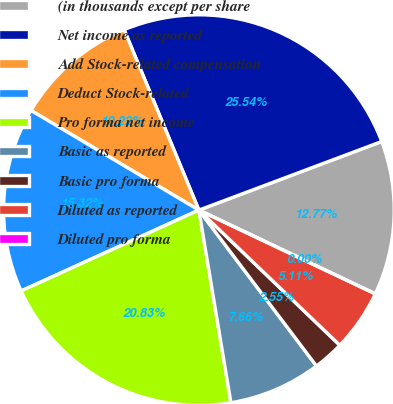<chart> <loc_0><loc_0><loc_500><loc_500><pie_chart><fcel>(in thousands except per share<fcel>Net income as reported<fcel>Add Stock-related compensation<fcel>Deduct Stock-related<fcel>Pro forma net income<fcel>Basic as reported<fcel>Basic pro forma<fcel>Diluted as reported<fcel>Diluted pro forma<nl><fcel>12.77%<fcel>25.54%<fcel>10.22%<fcel>15.32%<fcel>20.83%<fcel>7.66%<fcel>2.55%<fcel>5.11%<fcel>0.0%<nl></chart> 